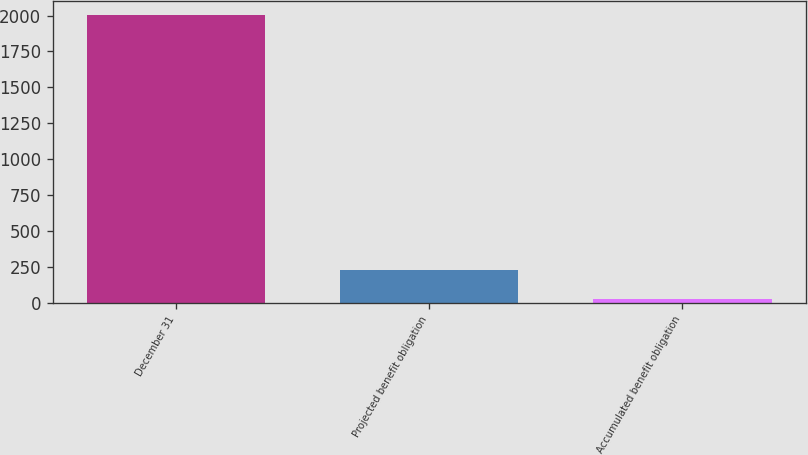Convert chart. <chart><loc_0><loc_0><loc_500><loc_500><bar_chart><fcel>December 31<fcel>Projected benefit obligation<fcel>Accumulated benefit obligation<nl><fcel>2004<fcel>224.88<fcel>27.2<nl></chart> 